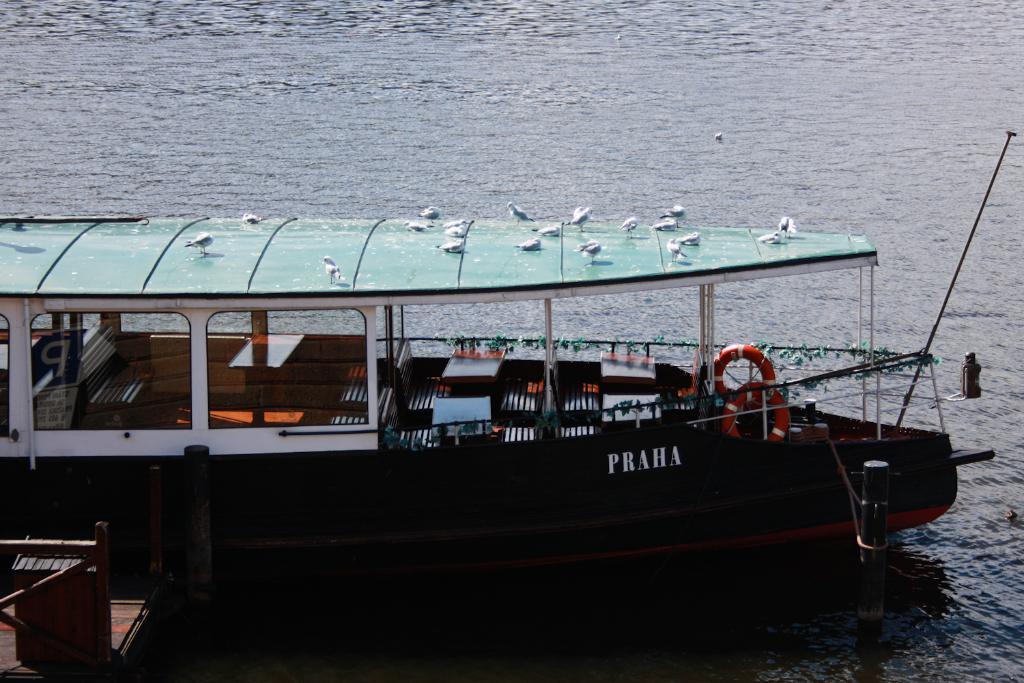In one or two sentences, can you explain what this image depicts? In the foreground of this image, there is a boat on which there are few birds. In the left bottom corner, it seems like a dock and at the top, there is water. 